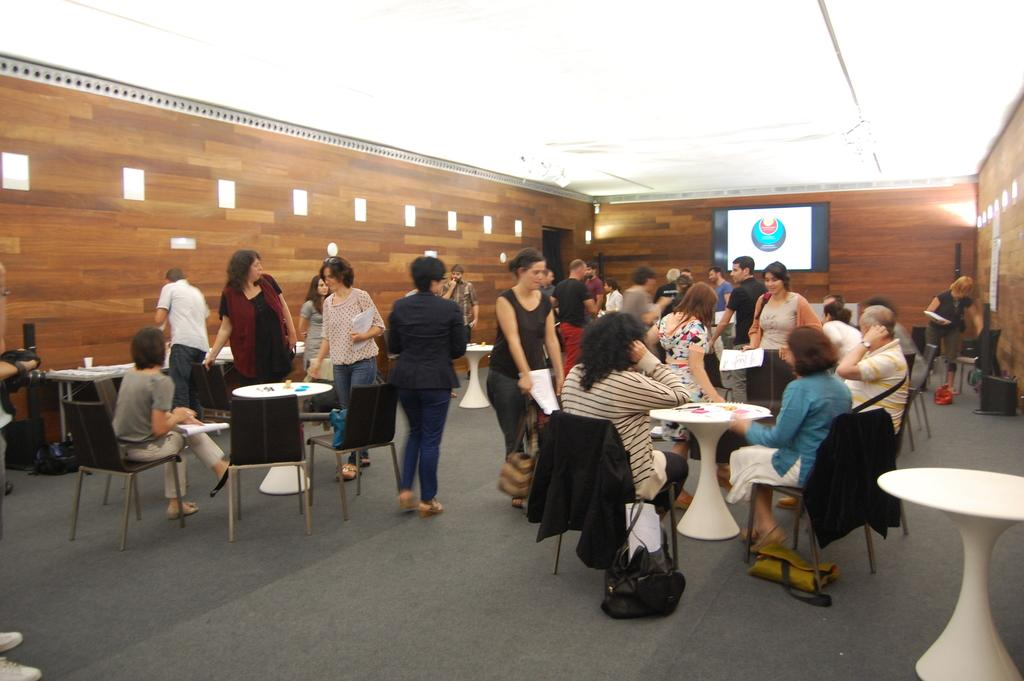How many people are present in the image? There are many people in the image. What are the people doing in the image? The people are sitting on chairs. How are the chairs arranged in the image? The chairs are arranged around a table. What can be seen in the background of the image? There is a screen in the background. What type of setting is depicted in the image? The setting appears to be a conference hall. What type of comb is being used by the fish in the image? There are no fish or combs present in the image. 